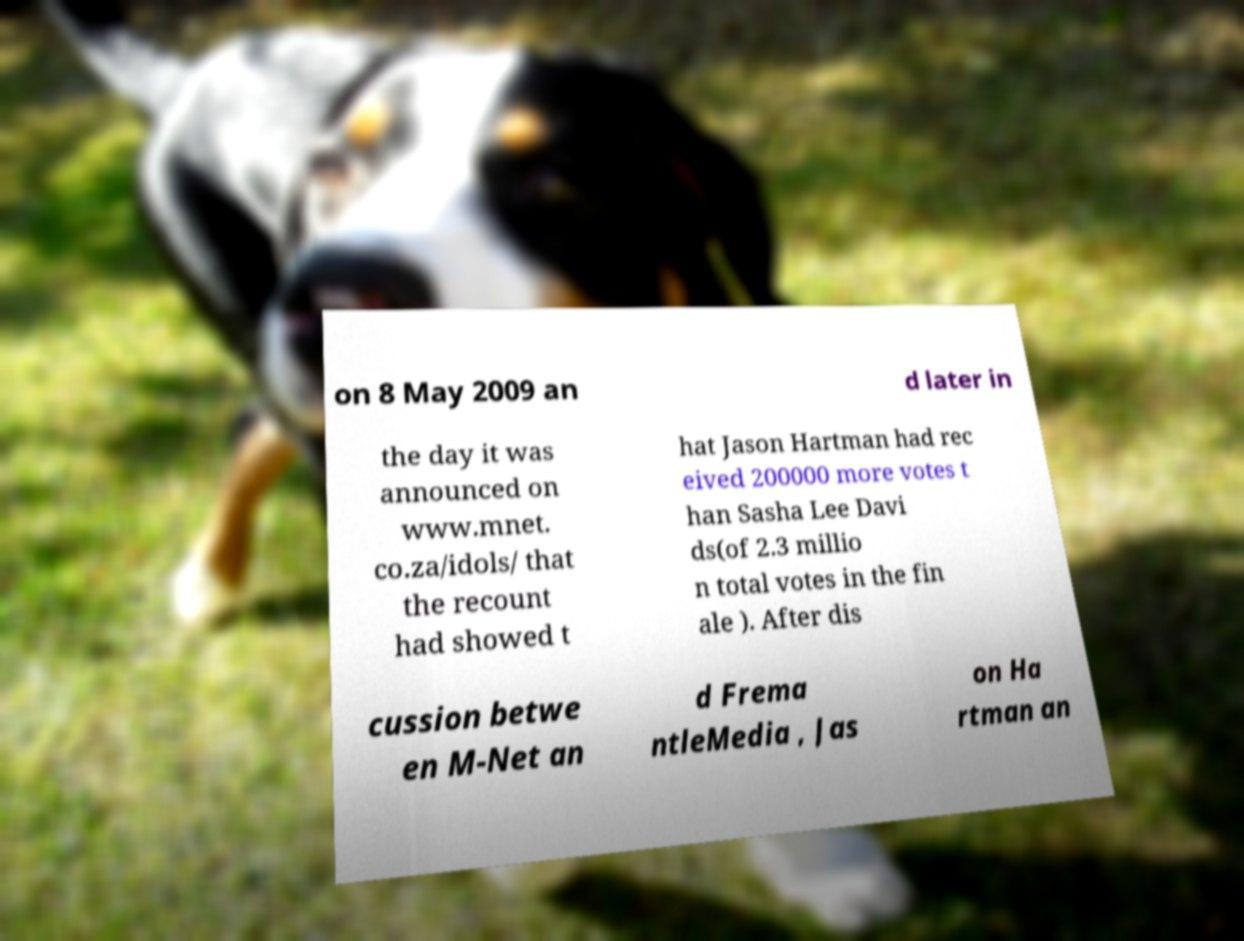For documentation purposes, I need the text within this image transcribed. Could you provide that? on 8 May 2009 an d later in the day it was announced on www.mnet. co.za/idols/ that the recount had showed t hat Jason Hartman had rec eived 200000 more votes t han Sasha Lee Davi ds(of 2.3 millio n total votes in the fin ale ). After dis cussion betwe en M-Net an d Frema ntleMedia , Jas on Ha rtman an 